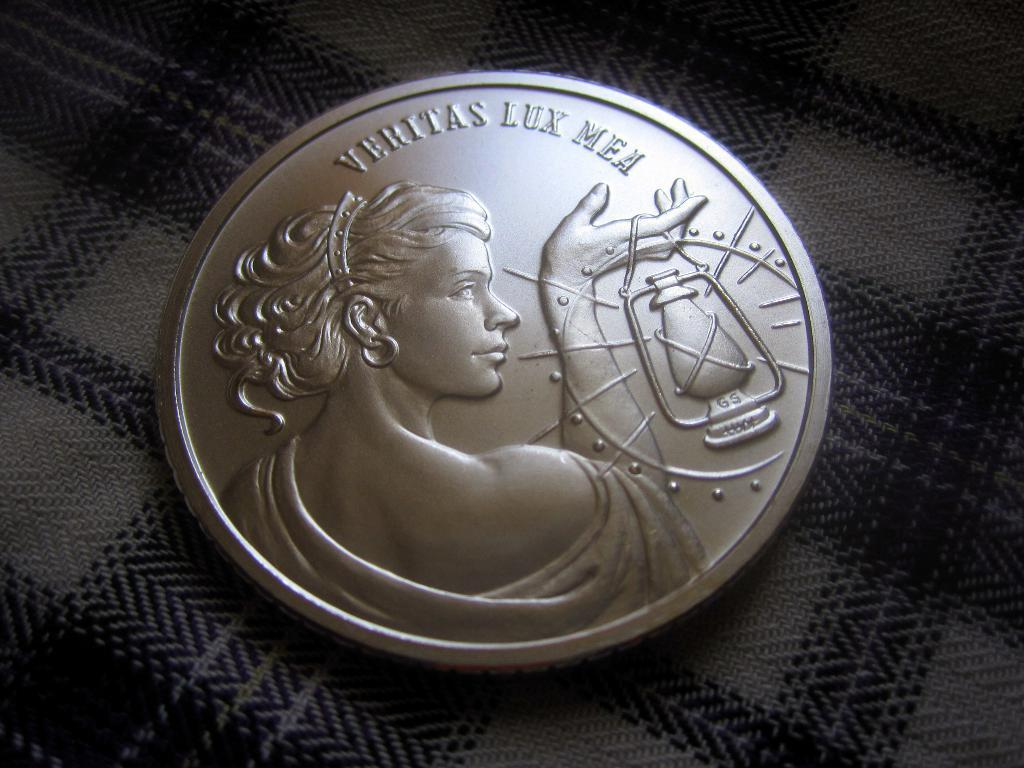<image>
Give a short and clear explanation of the subsequent image. A silver coin has a woman on the front and the inscription Veritas Lux Mea. 